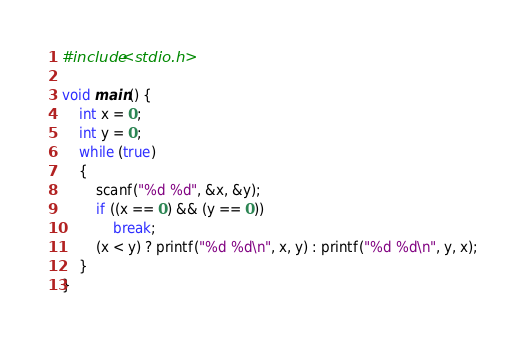<code> <loc_0><loc_0><loc_500><loc_500><_C_>#include<stdio.h>

void main() {
	int x = 0;
	int y = 0;
	while (true)
	{
		scanf("%d %d", &x, &y);
		if ((x == 0) && (y == 0))
			break;
		(x < y) ? printf("%d %d\n", x, y) : printf("%d %d\n", y, x);
	}
}</code> 